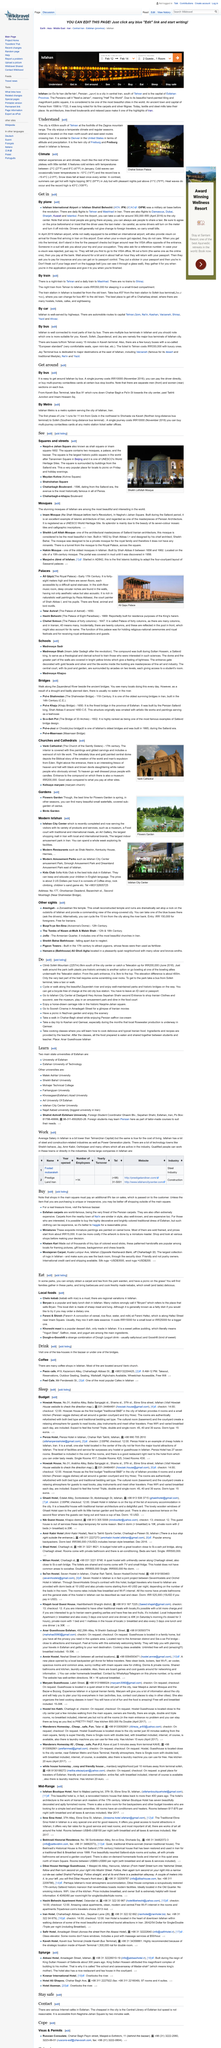Outline some significant characteristics in this image. The record high temperature in Isfahan is 43 degrees Celsius, which is equivalent to 109 degrees Fahrenheit. It is recommended to use buses to get around Isfahan. Yes, the bus drivers in Isfahan can be paid directly. Isfahan in the United States is similar to Denver in terms of altitude and precipitation. Isfahan has a twin city named Freiburg. 